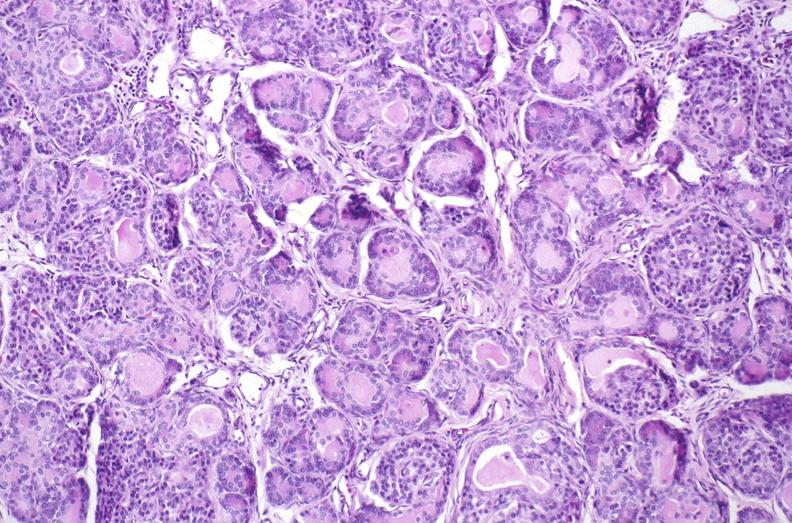what does this image show?
Answer the question using a single word or phrase. Cystic fibrosis 